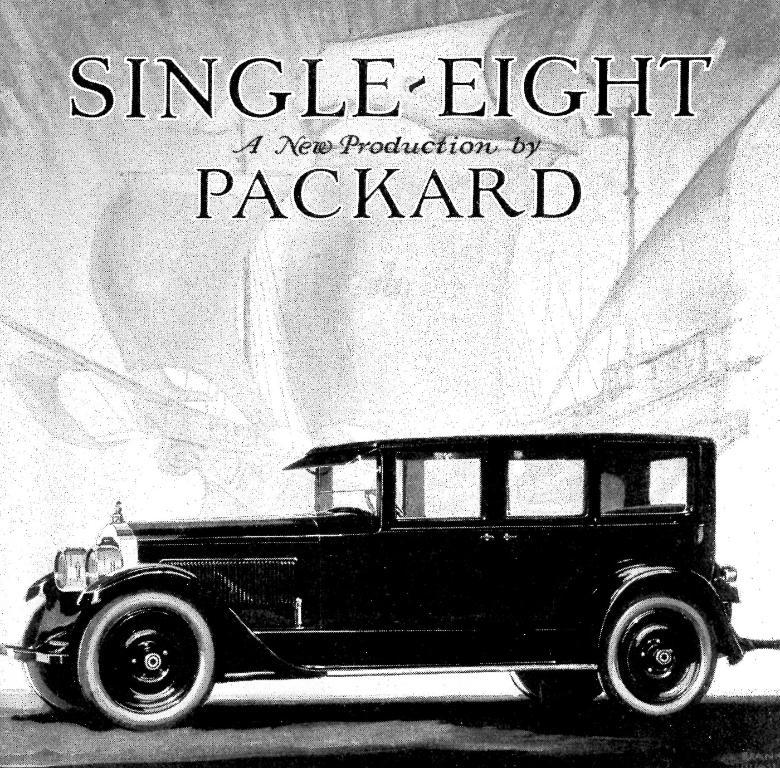What is the main subject of the poster in the image? The poster features a black color car. What else can be seen on the poster besides the car? There is text written on the poster. What type of vehicle is visible in the background of the image? There is a trireme visible in the background of the image. What type of suit is the marble wearing in the image? There is no suit or marble present in the image. 